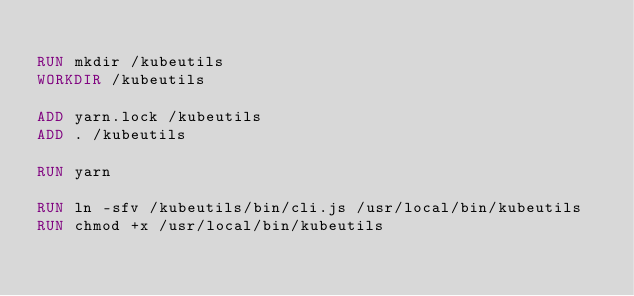Convert code to text. <code><loc_0><loc_0><loc_500><loc_500><_Dockerfile_>
RUN mkdir /kubeutils
WORKDIR /kubeutils

ADD yarn.lock /kubeutils
ADD . /kubeutils

RUN yarn

RUN ln -sfv /kubeutils/bin/cli.js /usr/local/bin/kubeutils
RUN chmod +x /usr/local/bin/kubeutils
</code> 